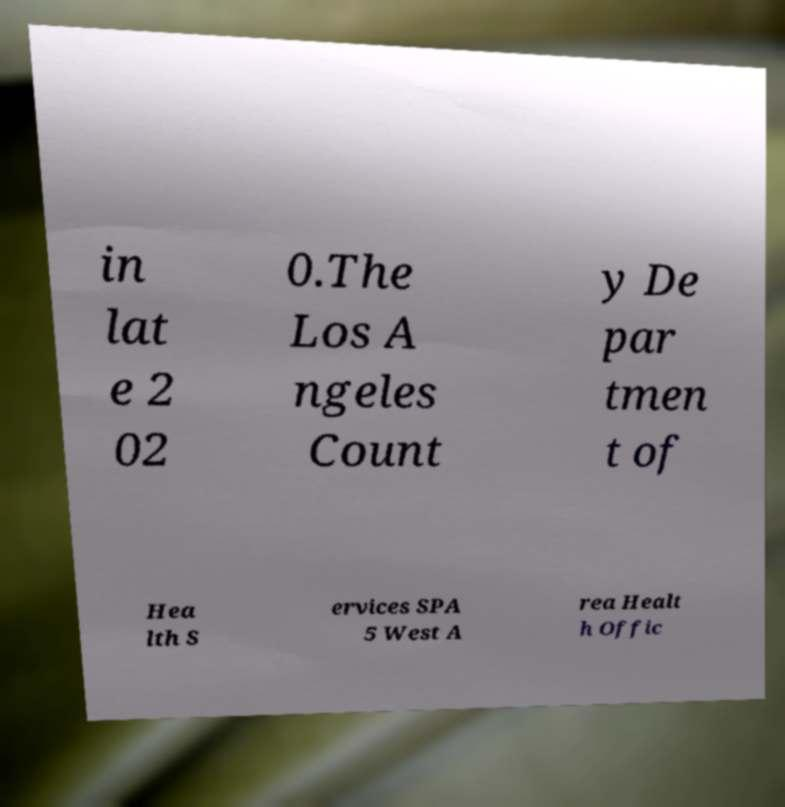Please read and relay the text visible in this image. What does it say? in lat e 2 02 0.The Los A ngeles Count y De par tmen t of Hea lth S ervices SPA 5 West A rea Healt h Offic 